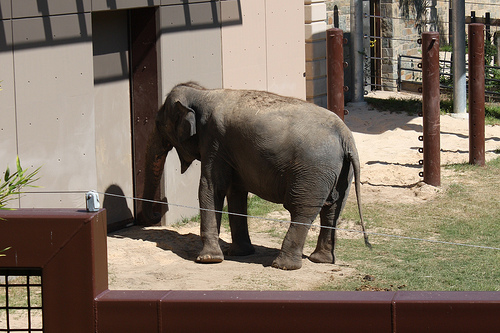<image>
Can you confirm if the elephant is behind the building? Yes. From this viewpoint, the elephant is positioned behind the building, with the building partially or fully occluding the elephant. Where is the elephant in relation to the door? Is it to the right of the door? Yes. From this viewpoint, the elephant is positioned to the right side relative to the door. 